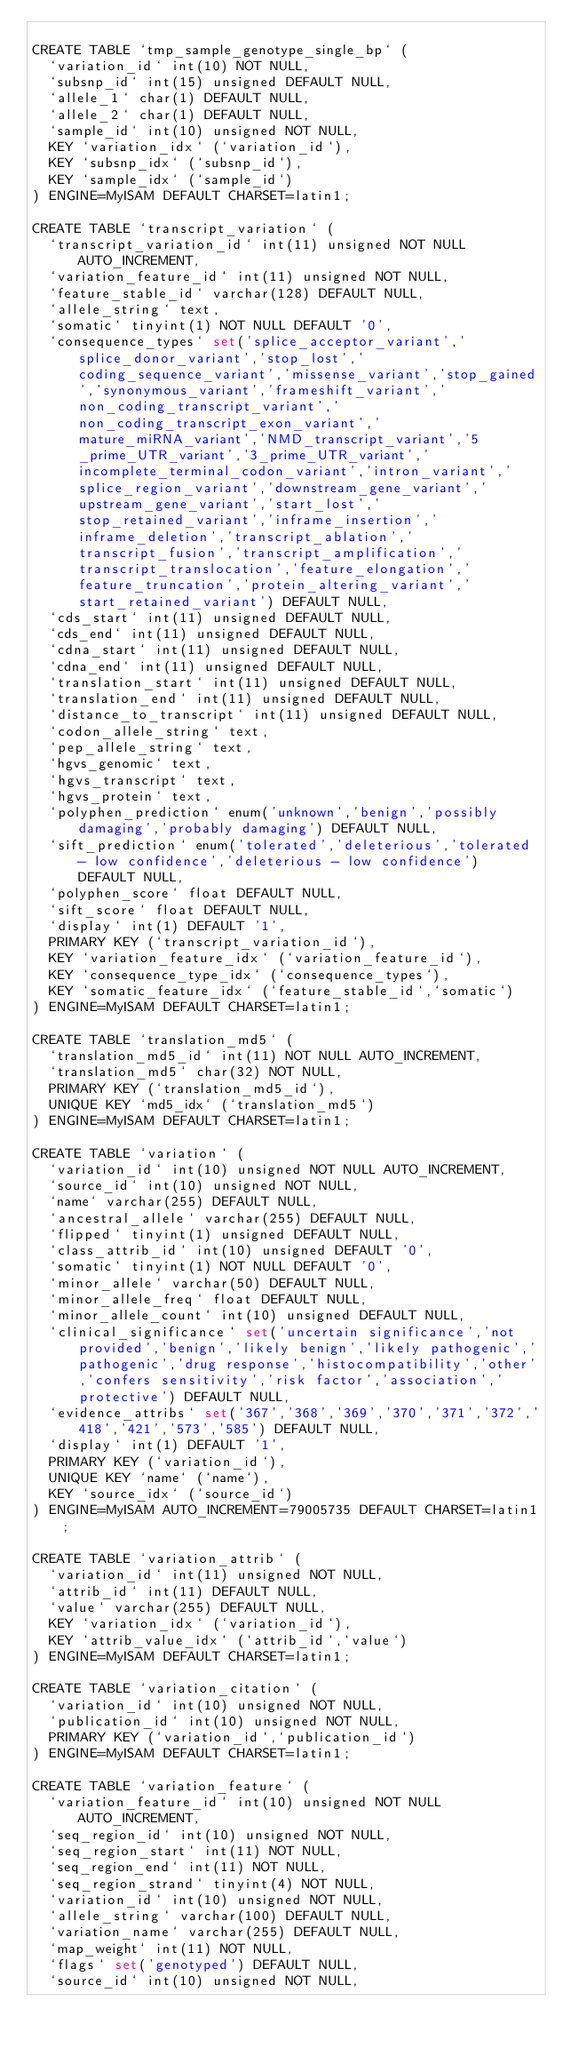<code> <loc_0><loc_0><loc_500><loc_500><_SQL_>
CREATE TABLE `tmp_sample_genotype_single_bp` (
  `variation_id` int(10) NOT NULL,
  `subsnp_id` int(15) unsigned DEFAULT NULL,
  `allele_1` char(1) DEFAULT NULL,
  `allele_2` char(1) DEFAULT NULL,
  `sample_id` int(10) unsigned NOT NULL,
  KEY `variation_idx` (`variation_id`),
  KEY `subsnp_idx` (`subsnp_id`),
  KEY `sample_idx` (`sample_id`)
) ENGINE=MyISAM DEFAULT CHARSET=latin1;

CREATE TABLE `transcript_variation` (
  `transcript_variation_id` int(11) unsigned NOT NULL AUTO_INCREMENT,
  `variation_feature_id` int(11) unsigned NOT NULL,
  `feature_stable_id` varchar(128) DEFAULT NULL,
  `allele_string` text,
  `somatic` tinyint(1) NOT NULL DEFAULT '0',
  `consequence_types` set('splice_acceptor_variant','splice_donor_variant','stop_lost','coding_sequence_variant','missense_variant','stop_gained','synonymous_variant','frameshift_variant','non_coding_transcript_variant','non_coding_transcript_exon_variant','mature_miRNA_variant','NMD_transcript_variant','5_prime_UTR_variant','3_prime_UTR_variant','incomplete_terminal_codon_variant','intron_variant','splice_region_variant','downstream_gene_variant','upstream_gene_variant','start_lost','stop_retained_variant','inframe_insertion','inframe_deletion','transcript_ablation','transcript_fusion','transcript_amplification','transcript_translocation','feature_elongation','feature_truncation','protein_altering_variant','start_retained_variant') DEFAULT NULL,
  `cds_start` int(11) unsigned DEFAULT NULL,
  `cds_end` int(11) unsigned DEFAULT NULL,
  `cdna_start` int(11) unsigned DEFAULT NULL,
  `cdna_end` int(11) unsigned DEFAULT NULL,
  `translation_start` int(11) unsigned DEFAULT NULL,
  `translation_end` int(11) unsigned DEFAULT NULL,
  `distance_to_transcript` int(11) unsigned DEFAULT NULL,
  `codon_allele_string` text,
  `pep_allele_string` text,
  `hgvs_genomic` text,
  `hgvs_transcript` text,
  `hgvs_protein` text,
  `polyphen_prediction` enum('unknown','benign','possibly damaging','probably damaging') DEFAULT NULL,
  `sift_prediction` enum('tolerated','deleterious','tolerated - low confidence','deleterious - low confidence') DEFAULT NULL,
  `polyphen_score` float DEFAULT NULL,
  `sift_score` float DEFAULT NULL,
  `display` int(1) DEFAULT '1',
  PRIMARY KEY (`transcript_variation_id`),
  KEY `variation_feature_idx` (`variation_feature_id`),
  KEY `consequence_type_idx` (`consequence_types`),
  KEY `somatic_feature_idx` (`feature_stable_id`,`somatic`)
) ENGINE=MyISAM DEFAULT CHARSET=latin1;

CREATE TABLE `translation_md5` (
  `translation_md5_id` int(11) NOT NULL AUTO_INCREMENT,
  `translation_md5` char(32) NOT NULL,
  PRIMARY KEY (`translation_md5_id`),
  UNIQUE KEY `md5_idx` (`translation_md5`)
) ENGINE=MyISAM DEFAULT CHARSET=latin1;

CREATE TABLE `variation` (
  `variation_id` int(10) unsigned NOT NULL AUTO_INCREMENT,
  `source_id` int(10) unsigned NOT NULL,
  `name` varchar(255) DEFAULT NULL,
  `ancestral_allele` varchar(255) DEFAULT NULL,
  `flipped` tinyint(1) unsigned DEFAULT NULL,
  `class_attrib_id` int(10) unsigned DEFAULT '0',
  `somatic` tinyint(1) NOT NULL DEFAULT '0',
  `minor_allele` varchar(50) DEFAULT NULL,
  `minor_allele_freq` float DEFAULT NULL,
  `minor_allele_count` int(10) unsigned DEFAULT NULL,
  `clinical_significance` set('uncertain significance','not provided','benign','likely benign','likely pathogenic','pathogenic','drug response','histocompatibility','other','confers sensitivity','risk factor','association','protective') DEFAULT NULL,
  `evidence_attribs` set('367','368','369','370','371','372','418','421','573','585') DEFAULT NULL,
  `display` int(1) DEFAULT '1',
  PRIMARY KEY (`variation_id`),
  UNIQUE KEY `name` (`name`),
  KEY `source_idx` (`source_id`)
) ENGINE=MyISAM AUTO_INCREMENT=79005735 DEFAULT CHARSET=latin1;

CREATE TABLE `variation_attrib` (
  `variation_id` int(11) unsigned NOT NULL,
  `attrib_id` int(11) DEFAULT NULL,
  `value` varchar(255) DEFAULT NULL,
  KEY `variation_idx` (`variation_id`),
  KEY `attrib_value_idx` (`attrib_id`,`value`)
) ENGINE=MyISAM DEFAULT CHARSET=latin1;

CREATE TABLE `variation_citation` (
  `variation_id` int(10) unsigned NOT NULL,
  `publication_id` int(10) unsigned NOT NULL,
  PRIMARY KEY (`variation_id`,`publication_id`)
) ENGINE=MyISAM DEFAULT CHARSET=latin1;

CREATE TABLE `variation_feature` (
  `variation_feature_id` int(10) unsigned NOT NULL AUTO_INCREMENT,
  `seq_region_id` int(10) unsigned NOT NULL,
  `seq_region_start` int(11) NOT NULL,
  `seq_region_end` int(11) NOT NULL,
  `seq_region_strand` tinyint(4) NOT NULL,
  `variation_id` int(10) unsigned NOT NULL,
  `allele_string` varchar(100) DEFAULT NULL,
  `variation_name` varchar(255) DEFAULT NULL,
  `map_weight` int(11) NOT NULL,
  `flags` set('genotyped') DEFAULT NULL,
  `source_id` int(10) unsigned NOT NULL,</code> 